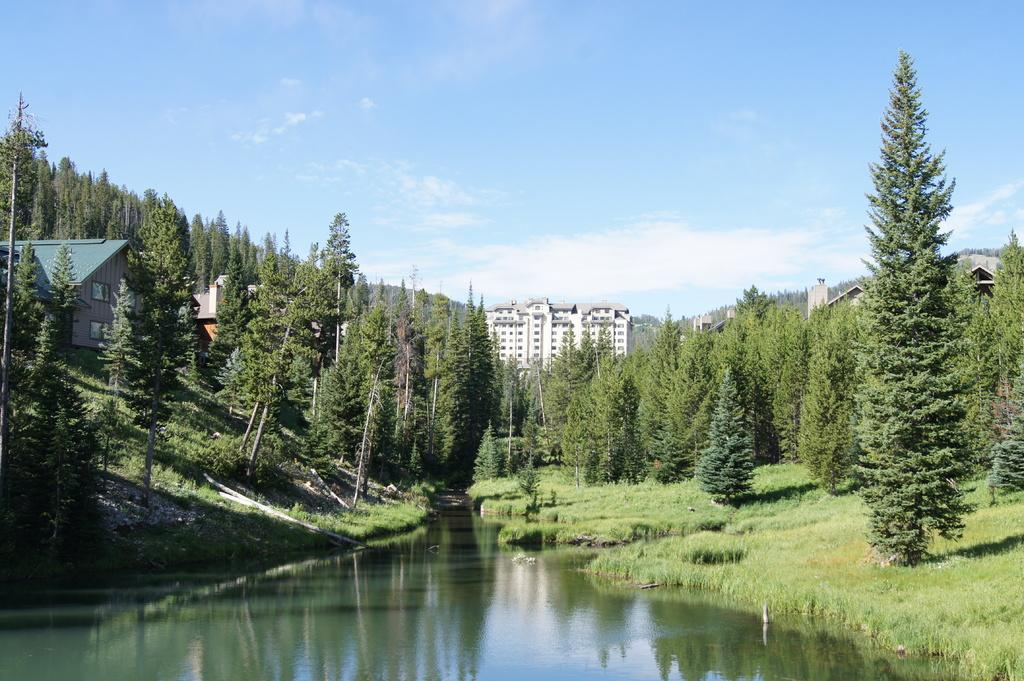What type of structures can be seen in the image? There are houses in the image. What type of vegetation is present in the image? There are trees in the image. What type of ground cover is visible in the image? There is grass in the image. What body of water is present in the image? There is a lake in the image. What part of the natural environment is visible in the image? The sky is visible in the image. What color is the silver tent in the image? There is no silver tent present in the image. Whose finger can be seen pointing at the lake in the image? There are no fingers or people pointing at the lake in the image. 